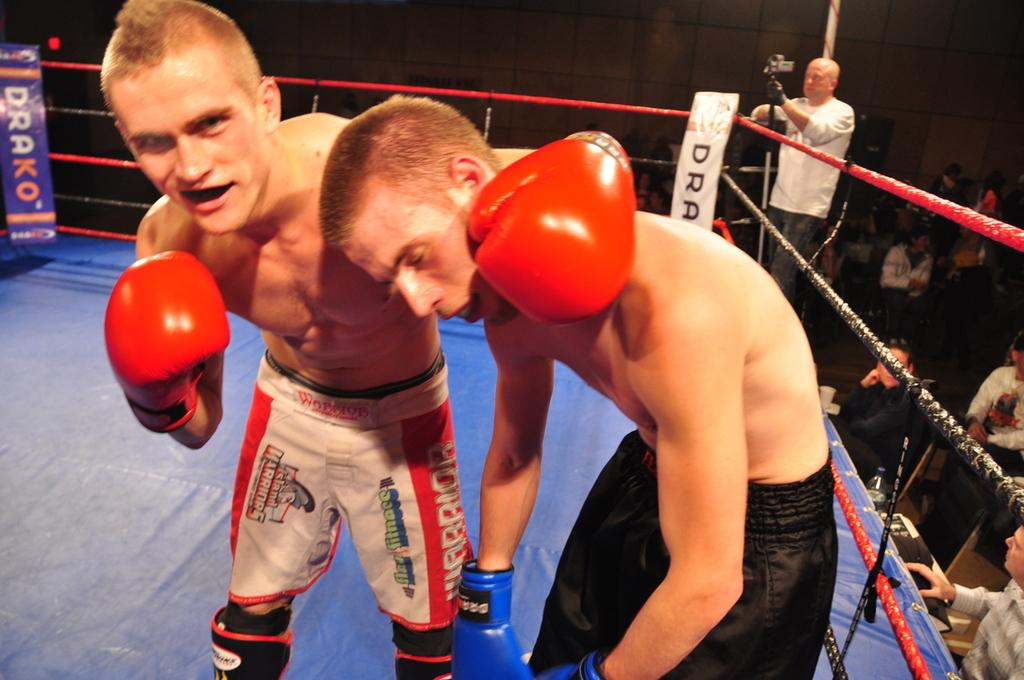What is the main subject of the image? The main subjects of the image are two wrestlers. Can you describe the clothing of the first wrestler? The first wrestler is wearing a black color short. How about the second wrestler? The second wrestler is wearing a red and white color short. What type of frog can be seen sitting on the wrestler's ear in the image? There is no frog present in the image, and neither wrestler has a frog on their ear. 